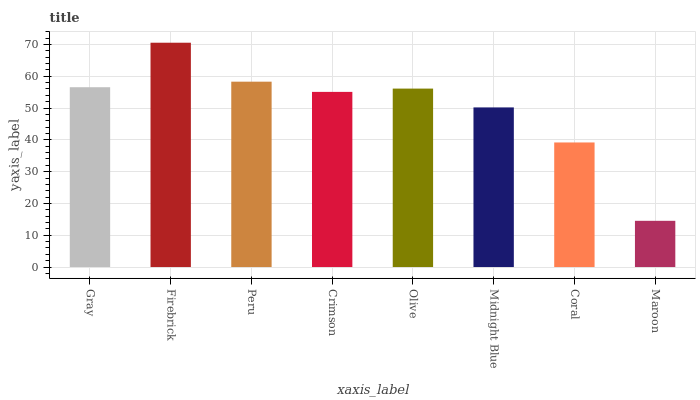Is Maroon the minimum?
Answer yes or no. Yes. Is Firebrick the maximum?
Answer yes or no. Yes. Is Peru the minimum?
Answer yes or no. No. Is Peru the maximum?
Answer yes or no. No. Is Firebrick greater than Peru?
Answer yes or no. Yes. Is Peru less than Firebrick?
Answer yes or no. Yes. Is Peru greater than Firebrick?
Answer yes or no. No. Is Firebrick less than Peru?
Answer yes or no. No. Is Olive the high median?
Answer yes or no. Yes. Is Crimson the low median?
Answer yes or no. Yes. Is Gray the high median?
Answer yes or no. No. Is Gray the low median?
Answer yes or no. No. 